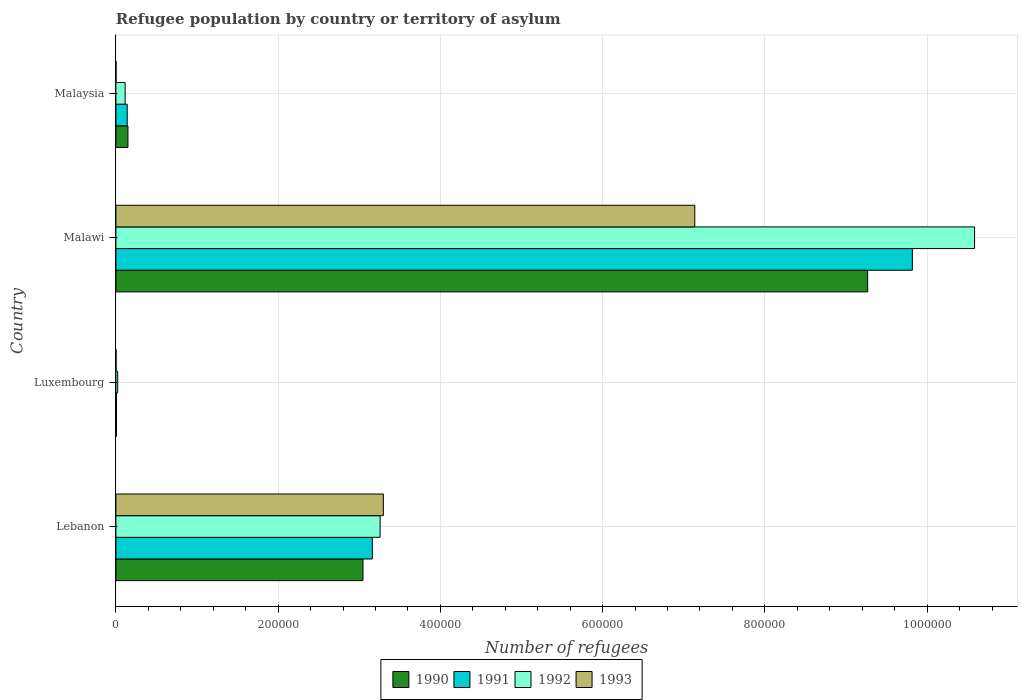Are the number of bars on each tick of the Y-axis equal?
Make the answer very short. Yes. What is the label of the 3rd group of bars from the top?
Offer a terse response. Luxembourg. In how many cases, is the number of bars for a given country not equal to the number of legend labels?
Provide a short and direct response. 0. What is the number of refugees in 1992 in Luxembourg?
Keep it short and to the point. 2208. Across all countries, what is the maximum number of refugees in 1990?
Your answer should be very brief. 9.27e+05. Across all countries, what is the minimum number of refugees in 1990?
Your answer should be compact. 687. In which country was the number of refugees in 1993 maximum?
Your response must be concise. Malawi. In which country was the number of refugees in 1992 minimum?
Offer a very short reply. Luxembourg. What is the total number of refugees in 1993 in the graph?
Offer a terse response. 1.04e+06. What is the difference between the number of refugees in 1990 in Lebanon and that in Malaysia?
Provide a succinct answer. 2.90e+05. What is the difference between the number of refugees in 1991 in Malaysia and the number of refugees in 1990 in Malawi?
Provide a succinct answer. -9.13e+05. What is the average number of refugees in 1993 per country?
Keep it short and to the point. 2.61e+05. What is the difference between the number of refugees in 1993 and number of refugees in 1992 in Lebanon?
Provide a short and direct response. 3998. In how many countries, is the number of refugees in 1993 greater than 40000 ?
Your answer should be very brief. 2. What is the ratio of the number of refugees in 1991 in Malawi to that in Malaysia?
Offer a very short reply. 70.4. Is the difference between the number of refugees in 1993 in Lebanon and Malaysia greater than the difference between the number of refugees in 1992 in Lebanon and Malaysia?
Offer a terse response. Yes. What is the difference between the highest and the second highest number of refugees in 1993?
Keep it short and to the point. 3.84e+05. What is the difference between the highest and the lowest number of refugees in 1991?
Give a very brief answer. 9.81e+05. Is the sum of the number of refugees in 1991 in Malawi and Malaysia greater than the maximum number of refugees in 1993 across all countries?
Your answer should be very brief. Yes. What does the 3rd bar from the bottom in Lebanon represents?
Keep it short and to the point. 1992. Is it the case that in every country, the sum of the number of refugees in 1991 and number of refugees in 1993 is greater than the number of refugees in 1992?
Provide a short and direct response. No. How many bars are there?
Your response must be concise. 16. What is the difference between two consecutive major ticks on the X-axis?
Give a very brief answer. 2.00e+05. Are the values on the major ticks of X-axis written in scientific E-notation?
Your answer should be very brief. No. Does the graph contain grids?
Make the answer very short. Yes. Where does the legend appear in the graph?
Offer a terse response. Bottom center. How are the legend labels stacked?
Make the answer very short. Horizontal. What is the title of the graph?
Keep it short and to the point. Refugee population by country or territory of asylum. Does "1975" appear as one of the legend labels in the graph?
Your answer should be very brief. No. What is the label or title of the X-axis?
Offer a very short reply. Number of refugees. What is the label or title of the Y-axis?
Provide a succinct answer. Country. What is the Number of refugees in 1990 in Lebanon?
Your response must be concise. 3.05e+05. What is the Number of refugees of 1991 in Lebanon?
Provide a succinct answer. 3.16e+05. What is the Number of refugees of 1992 in Lebanon?
Provide a short and direct response. 3.26e+05. What is the Number of refugees of 1993 in Lebanon?
Your response must be concise. 3.30e+05. What is the Number of refugees of 1990 in Luxembourg?
Provide a succinct answer. 687. What is the Number of refugees in 1991 in Luxembourg?
Make the answer very short. 692. What is the Number of refugees of 1992 in Luxembourg?
Offer a very short reply. 2208. What is the Number of refugees in 1993 in Luxembourg?
Your answer should be compact. 225. What is the Number of refugees in 1990 in Malawi?
Give a very brief answer. 9.27e+05. What is the Number of refugees in 1991 in Malawi?
Provide a short and direct response. 9.82e+05. What is the Number of refugees of 1992 in Malawi?
Your response must be concise. 1.06e+06. What is the Number of refugees in 1993 in Malawi?
Keep it short and to the point. 7.14e+05. What is the Number of refugees of 1990 in Malaysia?
Provide a short and direct response. 1.49e+04. What is the Number of refugees of 1991 in Malaysia?
Make the answer very short. 1.39e+04. What is the Number of refugees of 1992 in Malaysia?
Offer a very short reply. 1.14e+04. What is the Number of refugees in 1993 in Malaysia?
Offer a terse response. 154. Across all countries, what is the maximum Number of refugees in 1990?
Make the answer very short. 9.27e+05. Across all countries, what is the maximum Number of refugees of 1991?
Give a very brief answer. 9.82e+05. Across all countries, what is the maximum Number of refugees in 1992?
Provide a succinct answer. 1.06e+06. Across all countries, what is the maximum Number of refugees in 1993?
Your answer should be very brief. 7.14e+05. Across all countries, what is the minimum Number of refugees of 1990?
Provide a succinct answer. 687. Across all countries, what is the minimum Number of refugees in 1991?
Offer a very short reply. 692. Across all countries, what is the minimum Number of refugees in 1992?
Your response must be concise. 2208. Across all countries, what is the minimum Number of refugees of 1993?
Offer a very short reply. 154. What is the total Number of refugees of 1990 in the graph?
Your answer should be very brief. 1.25e+06. What is the total Number of refugees of 1991 in the graph?
Provide a short and direct response. 1.31e+06. What is the total Number of refugees of 1992 in the graph?
Your response must be concise. 1.40e+06. What is the total Number of refugees in 1993 in the graph?
Keep it short and to the point. 1.04e+06. What is the difference between the Number of refugees of 1990 in Lebanon and that in Luxembourg?
Your response must be concise. 3.04e+05. What is the difference between the Number of refugees of 1991 in Lebanon and that in Luxembourg?
Offer a terse response. 3.15e+05. What is the difference between the Number of refugees of 1992 in Lebanon and that in Luxembourg?
Your answer should be compact. 3.23e+05. What is the difference between the Number of refugees in 1993 in Lebanon and that in Luxembourg?
Offer a very short reply. 3.29e+05. What is the difference between the Number of refugees in 1990 in Lebanon and that in Malawi?
Offer a terse response. -6.22e+05. What is the difference between the Number of refugees of 1991 in Lebanon and that in Malawi?
Your answer should be compact. -6.66e+05. What is the difference between the Number of refugees in 1992 in Lebanon and that in Malawi?
Ensure brevity in your answer.  -7.33e+05. What is the difference between the Number of refugees of 1993 in Lebanon and that in Malawi?
Your answer should be compact. -3.84e+05. What is the difference between the Number of refugees of 1990 in Lebanon and that in Malaysia?
Your response must be concise. 2.90e+05. What is the difference between the Number of refugees of 1991 in Lebanon and that in Malaysia?
Ensure brevity in your answer.  3.02e+05. What is the difference between the Number of refugees in 1992 in Lebanon and that in Malaysia?
Provide a succinct answer. 3.14e+05. What is the difference between the Number of refugees in 1993 in Lebanon and that in Malaysia?
Ensure brevity in your answer.  3.30e+05. What is the difference between the Number of refugees in 1990 in Luxembourg and that in Malawi?
Provide a succinct answer. -9.26e+05. What is the difference between the Number of refugees of 1991 in Luxembourg and that in Malawi?
Provide a short and direct response. -9.81e+05. What is the difference between the Number of refugees in 1992 in Luxembourg and that in Malawi?
Give a very brief answer. -1.06e+06. What is the difference between the Number of refugees in 1993 in Luxembourg and that in Malawi?
Keep it short and to the point. -7.13e+05. What is the difference between the Number of refugees in 1990 in Luxembourg and that in Malaysia?
Provide a short and direct response. -1.42e+04. What is the difference between the Number of refugees of 1991 in Luxembourg and that in Malaysia?
Give a very brief answer. -1.33e+04. What is the difference between the Number of refugees in 1992 in Luxembourg and that in Malaysia?
Make the answer very short. -9191. What is the difference between the Number of refugees of 1990 in Malawi and that in Malaysia?
Provide a short and direct response. 9.12e+05. What is the difference between the Number of refugees of 1991 in Malawi and that in Malaysia?
Provide a succinct answer. 9.68e+05. What is the difference between the Number of refugees of 1992 in Malawi and that in Malaysia?
Your answer should be very brief. 1.05e+06. What is the difference between the Number of refugees of 1993 in Malawi and that in Malaysia?
Offer a terse response. 7.13e+05. What is the difference between the Number of refugees of 1990 in Lebanon and the Number of refugees of 1991 in Luxembourg?
Make the answer very short. 3.04e+05. What is the difference between the Number of refugees of 1990 in Lebanon and the Number of refugees of 1992 in Luxembourg?
Provide a short and direct response. 3.02e+05. What is the difference between the Number of refugees of 1990 in Lebanon and the Number of refugees of 1993 in Luxembourg?
Offer a very short reply. 3.04e+05. What is the difference between the Number of refugees in 1991 in Lebanon and the Number of refugees in 1992 in Luxembourg?
Keep it short and to the point. 3.14e+05. What is the difference between the Number of refugees in 1991 in Lebanon and the Number of refugees in 1993 in Luxembourg?
Your response must be concise. 3.16e+05. What is the difference between the Number of refugees of 1992 in Lebanon and the Number of refugees of 1993 in Luxembourg?
Your response must be concise. 3.25e+05. What is the difference between the Number of refugees of 1990 in Lebanon and the Number of refugees of 1991 in Malawi?
Your answer should be compact. -6.77e+05. What is the difference between the Number of refugees in 1990 in Lebanon and the Number of refugees in 1992 in Malawi?
Your answer should be compact. -7.54e+05. What is the difference between the Number of refugees of 1990 in Lebanon and the Number of refugees of 1993 in Malawi?
Your answer should be compact. -4.09e+05. What is the difference between the Number of refugees of 1991 in Lebanon and the Number of refugees of 1992 in Malawi?
Provide a short and direct response. -7.42e+05. What is the difference between the Number of refugees in 1991 in Lebanon and the Number of refugees in 1993 in Malawi?
Keep it short and to the point. -3.98e+05. What is the difference between the Number of refugees in 1992 in Lebanon and the Number of refugees in 1993 in Malawi?
Your answer should be compact. -3.88e+05. What is the difference between the Number of refugees in 1990 in Lebanon and the Number of refugees in 1991 in Malaysia?
Offer a very short reply. 2.91e+05. What is the difference between the Number of refugees in 1990 in Lebanon and the Number of refugees in 1992 in Malaysia?
Offer a terse response. 2.93e+05. What is the difference between the Number of refugees in 1990 in Lebanon and the Number of refugees in 1993 in Malaysia?
Provide a short and direct response. 3.04e+05. What is the difference between the Number of refugees of 1991 in Lebanon and the Number of refugees of 1992 in Malaysia?
Provide a short and direct response. 3.05e+05. What is the difference between the Number of refugees of 1991 in Lebanon and the Number of refugees of 1993 in Malaysia?
Keep it short and to the point. 3.16e+05. What is the difference between the Number of refugees in 1992 in Lebanon and the Number of refugees in 1993 in Malaysia?
Make the answer very short. 3.26e+05. What is the difference between the Number of refugees of 1990 in Luxembourg and the Number of refugees of 1991 in Malawi?
Give a very brief answer. -9.81e+05. What is the difference between the Number of refugees of 1990 in Luxembourg and the Number of refugees of 1992 in Malawi?
Keep it short and to the point. -1.06e+06. What is the difference between the Number of refugees of 1990 in Luxembourg and the Number of refugees of 1993 in Malawi?
Give a very brief answer. -7.13e+05. What is the difference between the Number of refugees of 1991 in Luxembourg and the Number of refugees of 1992 in Malawi?
Your answer should be compact. -1.06e+06. What is the difference between the Number of refugees in 1991 in Luxembourg and the Number of refugees in 1993 in Malawi?
Provide a succinct answer. -7.13e+05. What is the difference between the Number of refugees of 1992 in Luxembourg and the Number of refugees of 1993 in Malawi?
Your answer should be very brief. -7.11e+05. What is the difference between the Number of refugees of 1990 in Luxembourg and the Number of refugees of 1991 in Malaysia?
Ensure brevity in your answer.  -1.33e+04. What is the difference between the Number of refugees in 1990 in Luxembourg and the Number of refugees in 1992 in Malaysia?
Your answer should be compact. -1.07e+04. What is the difference between the Number of refugees of 1990 in Luxembourg and the Number of refugees of 1993 in Malaysia?
Make the answer very short. 533. What is the difference between the Number of refugees of 1991 in Luxembourg and the Number of refugees of 1992 in Malaysia?
Make the answer very short. -1.07e+04. What is the difference between the Number of refugees of 1991 in Luxembourg and the Number of refugees of 1993 in Malaysia?
Your answer should be compact. 538. What is the difference between the Number of refugees of 1992 in Luxembourg and the Number of refugees of 1993 in Malaysia?
Ensure brevity in your answer.  2054. What is the difference between the Number of refugees in 1990 in Malawi and the Number of refugees in 1991 in Malaysia?
Make the answer very short. 9.13e+05. What is the difference between the Number of refugees in 1990 in Malawi and the Number of refugees in 1992 in Malaysia?
Make the answer very short. 9.15e+05. What is the difference between the Number of refugees in 1990 in Malawi and the Number of refugees in 1993 in Malaysia?
Your response must be concise. 9.27e+05. What is the difference between the Number of refugees of 1991 in Malawi and the Number of refugees of 1992 in Malaysia?
Make the answer very short. 9.70e+05. What is the difference between the Number of refugees of 1991 in Malawi and the Number of refugees of 1993 in Malaysia?
Keep it short and to the point. 9.82e+05. What is the difference between the Number of refugees in 1992 in Malawi and the Number of refugees in 1993 in Malaysia?
Your response must be concise. 1.06e+06. What is the average Number of refugees of 1990 per country?
Offer a terse response. 3.12e+05. What is the average Number of refugees of 1991 per country?
Give a very brief answer. 3.28e+05. What is the average Number of refugees of 1992 per country?
Give a very brief answer. 3.49e+05. What is the average Number of refugees of 1993 per country?
Your answer should be very brief. 2.61e+05. What is the difference between the Number of refugees in 1990 and Number of refugees in 1991 in Lebanon?
Make the answer very short. -1.15e+04. What is the difference between the Number of refugees in 1990 and Number of refugees in 1992 in Lebanon?
Give a very brief answer. -2.11e+04. What is the difference between the Number of refugees in 1990 and Number of refugees in 1993 in Lebanon?
Offer a terse response. -2.51e+04. What is the difference between the Number of refugees in 1991 and Number of refugees in 1992 in Lebanon?
Give a very brief answer. -9612. What is the difference between the Number of refugees in 1991 and Number of refugees in 1993 in Lebanon?
Make the answer very short. -1.36e+04. What is the difference between the Number of refugees of 1992 and Number of refugees of 1993 in Lebanon?
Your answer should be very brief. -3998. What is the difference between the Number of refugees in 1990 and Number of refugees in 1992 in Luxembourg?
Keep it short and to the point. -1521. What is the difference between the Number of refugees in 1990 and Number of refugees in 1993 in Luxembourg?
Offer a very short reply. 462. What is the difference between the Number of refugees in 1991 and Number of refugees in 1992 in Luxembourg?
Offer a very short reply. -1516. What is the difference between the Number of refugees of 1991 and Number of refugees of 1993 in Luxembourg?
Give a very brief answer. 467. What is the difference between the Number of refugees of 1992 and Number of refugees of 1993 in Luxembourg?
Your answer should be compact. 1983. What is the difference between the Number of refugees of 1990 and Number of refugees of 1991 in Malawi?
Make the answer very short. -5.51e+04. What is the difference between the Number of refugees of 1990 and Number of refugees of 1992 in Malawi?
Offer a terse response. -1.32e+05. What is the difference between the Number of refugees in 1990 and Number of refugees in 1993 in Malawi?
Give a very brief answer. 2.13e+05. What is the difference between the Number of refugees of 1991 and Number of refugees of 1992 in Malawi?
Ensure brevity in your answer.  -7.67e+04. What is the difference between the Number of refugees of 1991 and Number of refugees of 1993 in Malawi?
Your answer should be compact. 2.68e+05. What is the difference between the Number of refugees of 1992 and Number of refugees of 1993 in Malawi?
Give a very brief answer. 3.45e+05. What is the difference between the Number of refugees of 1990 and Number of refugees of 1991 in Malaysia?
Your answer should be compact. 915. What is the difference between the Number of refugees in 1990 and Number of refugees in 1992 in Malaysia?
Keep it short and to the point. 3463. What is the difference between the Number of refugees in 1990 and Number of refugees in 1993 in Malaysia?
Your answer should be compact. 1.47e+04. What is the difference between the Number of refugees of 1991 and Number of refugees of 1992 in Malaysia?
Your response must be concise. 2548. What is the difference between the Number of refugees of 1991 and Number of refugees of 1993 in Malaysia?
Provide a short and direct response. 1.38e+04. What is the difference between the Number of refugees of 1992 and Number of refugees of 1993 in Malaysia?
Provide a short and direct response. 1.12e+04. What is the ratio of the Number of refugees in 1990 in Lebanon to that in Luxembourg?
Provide a succinct answer. 443.38. What is the ratio of the Number of refugees of 1991 in Lebanon to that in Luxembourg?
Offer a terse response. 456.78. What is the ratio of the Number of refugees of 1992 in Lebanon to that in Luxembourg?
Offer a terse response. 147.51. What is the ratio of the Number of refugees of 1993 in Lebanon to that in Luxembourg?
Offer a terse response. 1465.36. What is the ratio of the Number of refugees of 1990 in Lebanon to that in Malawi?
Ensure brevity in your answer.  0.33. What is the ratio of the Number of refugees in 1991 in Lebanon to that in Malawi?
Keep it short and to the point. 0.32. What is the ratio of the Number of refugees of 1992 in Lebanon to that in Malawi?
Make the answer very short. 0.31. What is the ratio of the Number of refugees of 1993 in Lebanon to that in Malawi?
Offer a very short reply. 0.46. What is the ratio of the Number of refugees of 1990 in Lebanon to that in Malaysia?
Provide a short and direct response. 20.5. What is the ratio of the Number of refugees of 1991 in Lebanon to that in Malaysia?
Your answer should be very brief. 22.66. What is the ratio of the Number of refugees in 1992 in Lebanon to that in Malaysia?
Keep it short and to the point. 28.57. What is the ratio of the Number of refugees in 1993 in Lebanon to that in Malaysia?
Offer a very short reply. 2140.94. What is the ratio of the Number of refugees in 1990 in Luxembourg to that in Malawi?
Provide a short and direct response. 0. What is the ratio of the Number of refugees of 1991 in Luxembourg to that in Malawi?
Your answer should be compact. 0. What is the ratio of the Number of refugees of 1992 in Luxembourg to that in Malawi?
Offer a terse response. 0. What is the ratio of the Number of refugees of 1993 in Luxembourg to that in Malawi?
Provide a succinct answer. 0. What is the ratio of the Number of refugees in 1990 in Luxembourg to that in Malaysia?
Make the answer very short. 0.05. What is the ratio of the Number of refugees of 1991 in Luxembourg to that in Malaysia?
Your response must be concise. 0.05. What is the ratio of the Number of refugees of 1992 in Luxembourg to that in Malaysia?
Offer a very short reply. 0.19. What is the ratio of the Number of refugees of 1993 in Luxembourg to that in Malaysia?
Keep it short and to the point. 1.46. What is the ratio of the Number of refugees in 1990 in Malawi to that in Malaysia?
Provide a short and direct response. 62.36. What is the ratio of the Number of refugees in 1991 in Malawi to that in Malaysia?
Offer a very short reply. 70.4. What is the ratio of the Number of refugees in 1992 in Malawi to that in Malaysia?
Provide a short and direct response. 92.86. What is the ratio of the Number of refugees in 1993 in Malawi to that in Malaysia?
Provide a short and direct response. 4633.81. What is the difference between the highest and the second highest Number of refugees in 1990?
Give a very brief answer. 6.22e+05. What is the difference between the highest and the second highest Number of refugees in 1991?
Make the answer very short. 6.66e+05. What is the difference between the highest and the second highest Number of refugees of 1992?
Ensure brevity in your answer.  7.33e+05. What is the difference between the highest and the second highest Number of refugees of 1993?
Give a very brief answer. 3.84e+05. What is the difference between the highest and the lowest Number of refugees in 1990?
Keep it short and to the point. 9.26e+05. What is the difference between the highest and the lowest Number of refugees of 1991?
Make the answer very short. 9.81e+05. What is the difference between the highest and the lowest Number of refugees of 1992?
Your answer should be compact. 1.06e+06. What is the difference between the highest and the lowest Number of refugees in 1993?
Offer a terse response. 7.13e+05. 